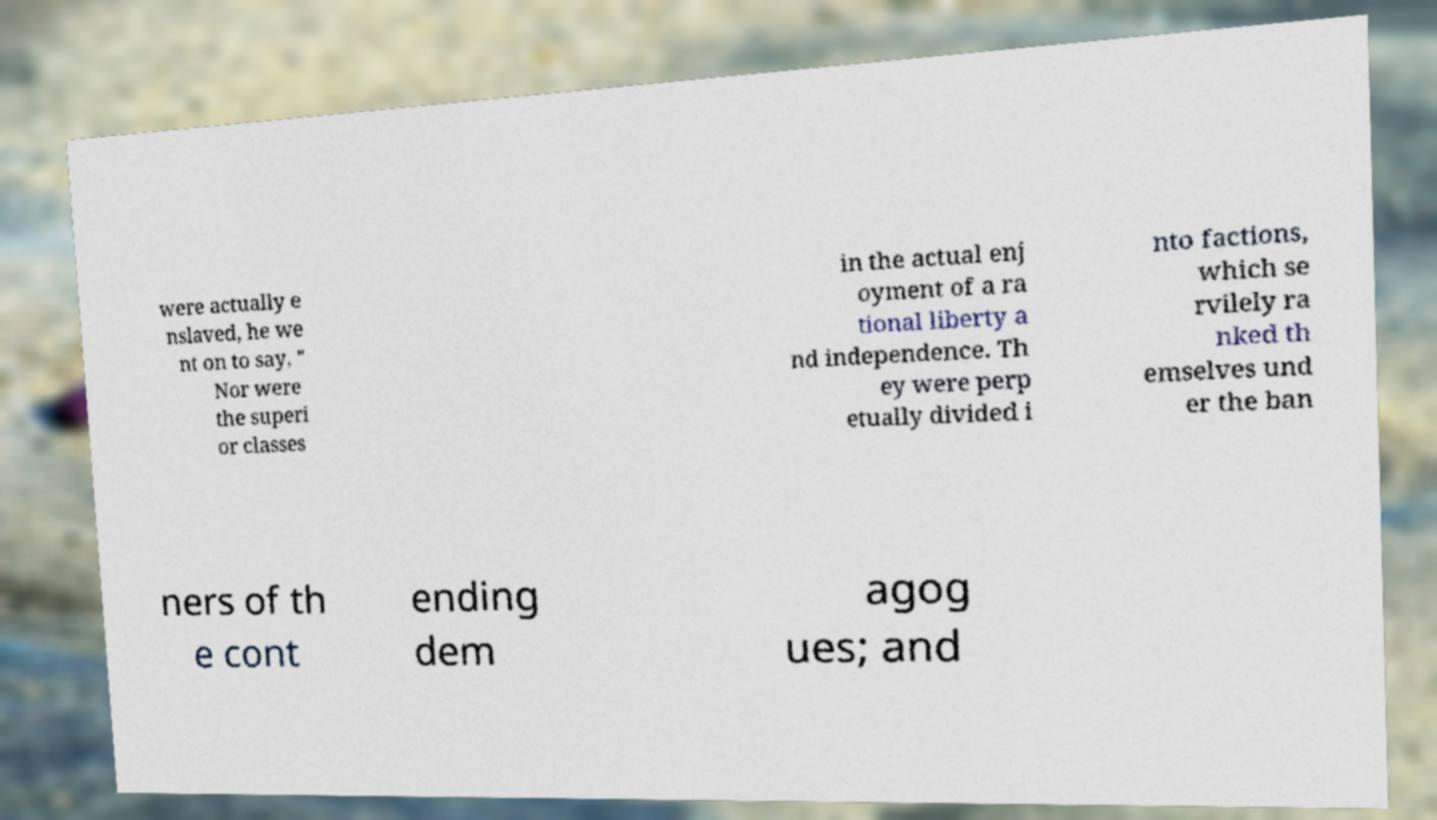What messages or text are displayed in this image? I need them in a readable, typed format. were actually e nslaved, he we nt on to say, " Nor were the superi or classes in the actual enj oyment of a ra tional liberty a nd independence. Th ey were perp etually divided i nto factions, which se rvilely ra nked th emselves und er the ban ners of th e cont ending dem agog ues; and 